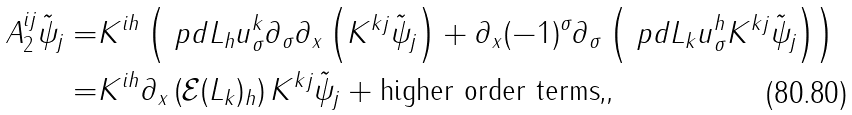<formula> <loc_0><loc_0><loc_500><loc_500>A _ { 2 } ^ { i j } \tilde { \psi } _ { j } = & K ^ { i h } \left ( \ p d { L _ { h } } { u ^ { k } _ { \sigma } } \partial _ { \sigma } \partial _ { x } \left ( K ^ { k j } \tilde { \psi } _ { j } \right ) + \partial _ { x } ( - 1 ) ^ { \sigma } \partial _ { \sigma } \left ( \ p d { L _ { k } } { u ^ { h } _ { \sigma } } K ^ { k j } \tilde { \psi } _ { j } \right ) \right ) \\ = & K ^ { i h } \partial _ { x } \left ( \mathcal { E } ( L _ { k } ) _ { h } \right ) K ^ { k j } \tilde { \psi } _ { j } + \text {higher order terms,} ,</formula> 